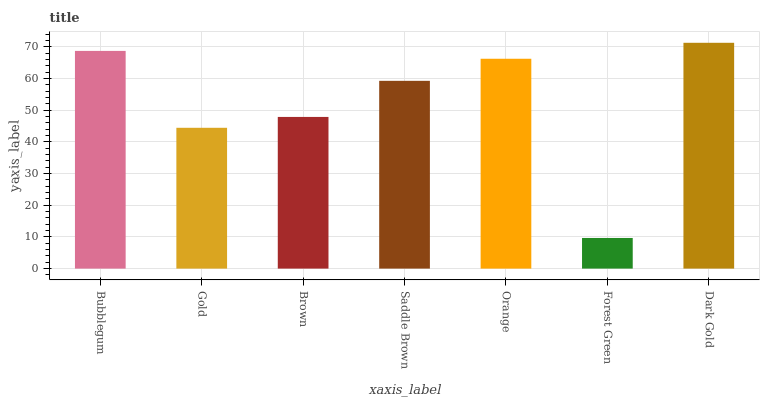Is Forest Green the minimum?
Answer yes or no. Yes. Is Dark Gold the maximum?
Answer yes or no. Yes. Is Gold the minimum?
Answer yes or no. No. Is Gold the maximum?
Answer yes or no. No. Is Bubblegum greater than Gold?
Answer yes or no. Yes. Is Gold less than Bubblegum?
Answer yes or no. Yes. Is Gold greater than Bubblegum?
Answer yes or no. No. Is Bubblegum less than Gold?
Answer yes or no. No. Is Saddle Brown the high median?
Answer yes or no. Yes. Is Saddle Brown the low median?
Answer yes or no. Yes. Is Forest Green the high median?
Answer yes or no. No. Is Bubblegum the low median?
Answer yes or no. No. 